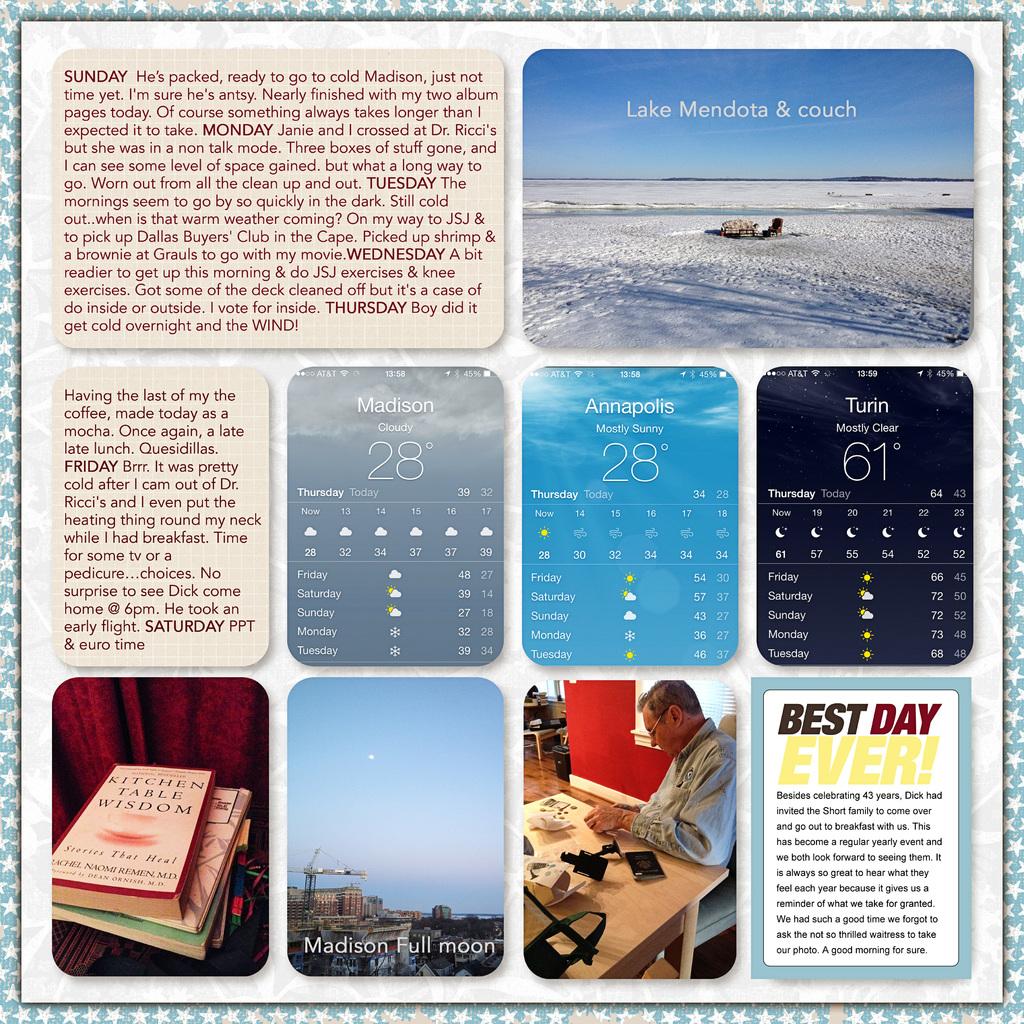What is the temperature in annapolis?
Offer a terse response. 28. Is it sunny or cloudy in madison?
Ensure brevity in your answer.  Cloudy. 